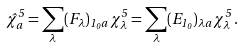Convert formula to latex. <formula><loc_0><loc_0><loc_500><loc_500>\hat { \chi } _ { a } ^ { 5 } = \sum _ { \lambda } ( F _ { \lambda } ) _ { 1 _ { 0 } a } \, \chi _ { \lambda } ^ { 5 } = \sum _ { \lambda } ( E _ { 1 _ { 0 } } ) _ { \lambda a } \, \chi _ { \lambda } ^ { 5 } \, .</formula> 